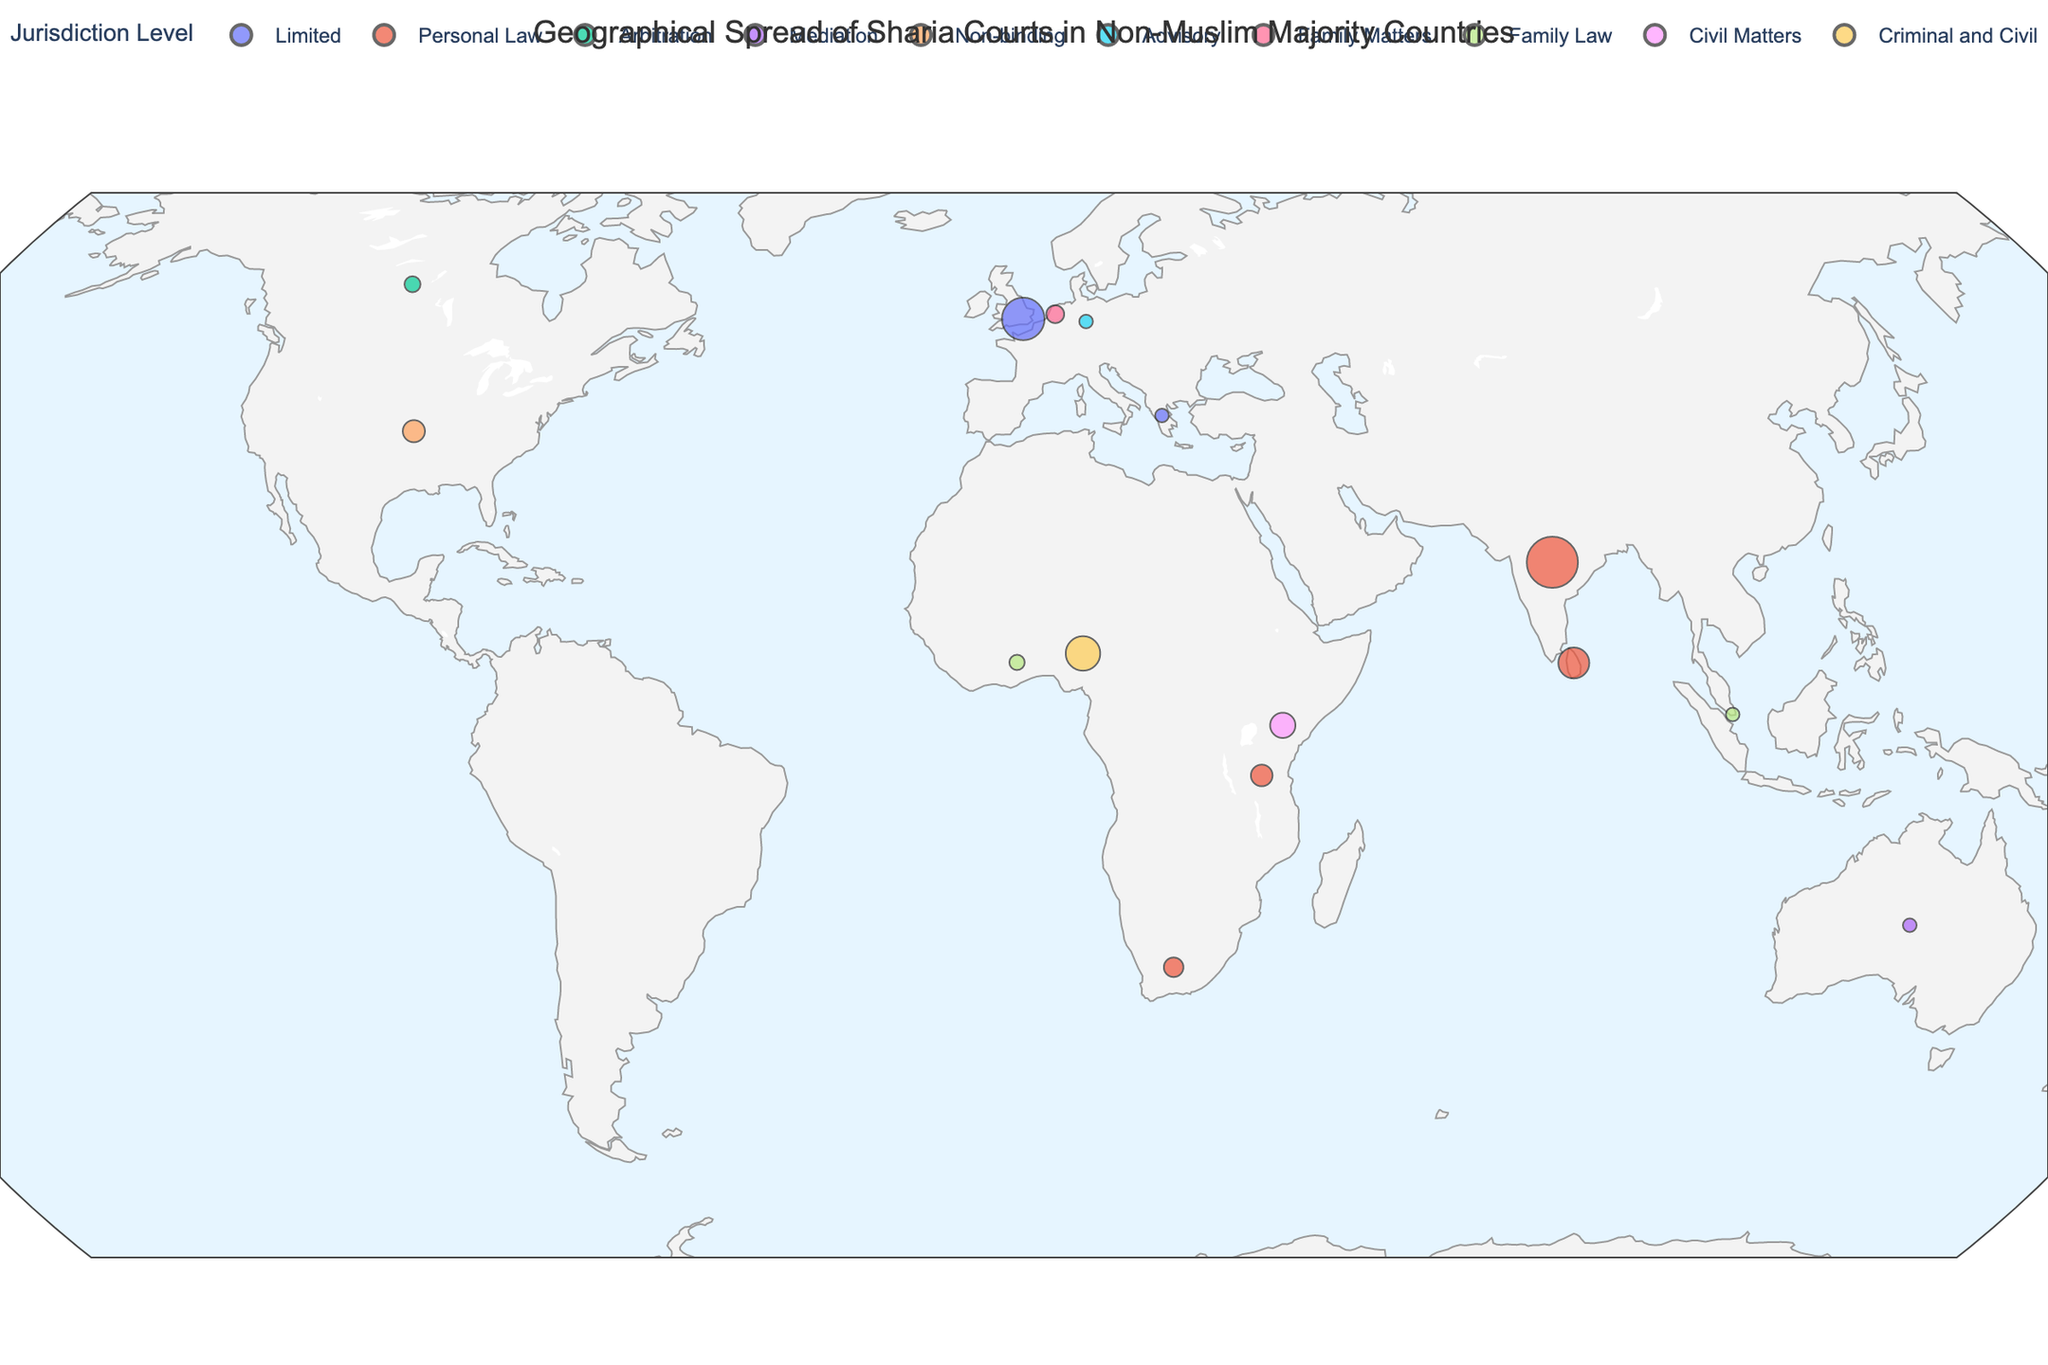How many countries have Sharia courts with 'Personal Law' jurisdiction? We need to count the number of countries with the 'Personal Law' jurisdiction visible on the map. These are: India, Sri Lanka, South Africa, and Tanzania.
Answer: 4 Which country has the largest number of Sharia courts? We look at the size of the markers on the map, the largest marker represents the UK. This is also confirmed by the data showing the UK has the highest count of 123 Sharia courts.
Answer: India What is the total number of Sharia courts across all countries? Sum the number of Sharia courts for all countries listed in the data: 85 + 123 + 12 + 7 + 23 + 5 + 15 + 3 + 45 + 8 + 18 + 30 + 56 + 11 + 22 = 463
Answer: 463 Which jurisdiction level is most common among the countries? We count the occurrences of each jurisdiction level from the map. 'Personal Law' appears most frequently in India, Sri Lanka, South Africa, and Tanzania.
Answer: Personal Law Compare the number of Sharia courts in India and Nigeria. Which country has more? Looking at the sizes of the markers on the map, and checking the counts in the data, India has 123 Sharia courts while Nigeria has 56. Thus, India has more.
Answer: India Which country in Europe has Sharia courts with 'Family Matters' jurisdiction? By examining the markers in Europe and their corresponding jurisdictions on the map, the Netherlands is identified as having 'Family Matters' jurisdiction.
Answer: Netherlands What is the average number of Sharia courts in the countries that have 'Family Law' jurisdiction? Calculate the average for countries with 'Family Law' jurisdiction, which are Singapore and Ghana with 8 and 11 courts. The average is (8 + 11) / 2 = 9.5
Answer: 9.5 Which African country has the highest number of Sharia courts and what is the jurisdiction level? Looking at the African region on the map, Nigeria has the largest marker, indicating it has the highest number of Sharia courts (56) with 'Criminal and Civil' jurisdiction.
Answer: Nigeria, Criminal and Civil How many countries have Sharia courts with 'Mediation' jurisdiction? The only country listed with 'Mediation' jurisdiction in the data and confirmed on the map is Australia.
Answer: 1 